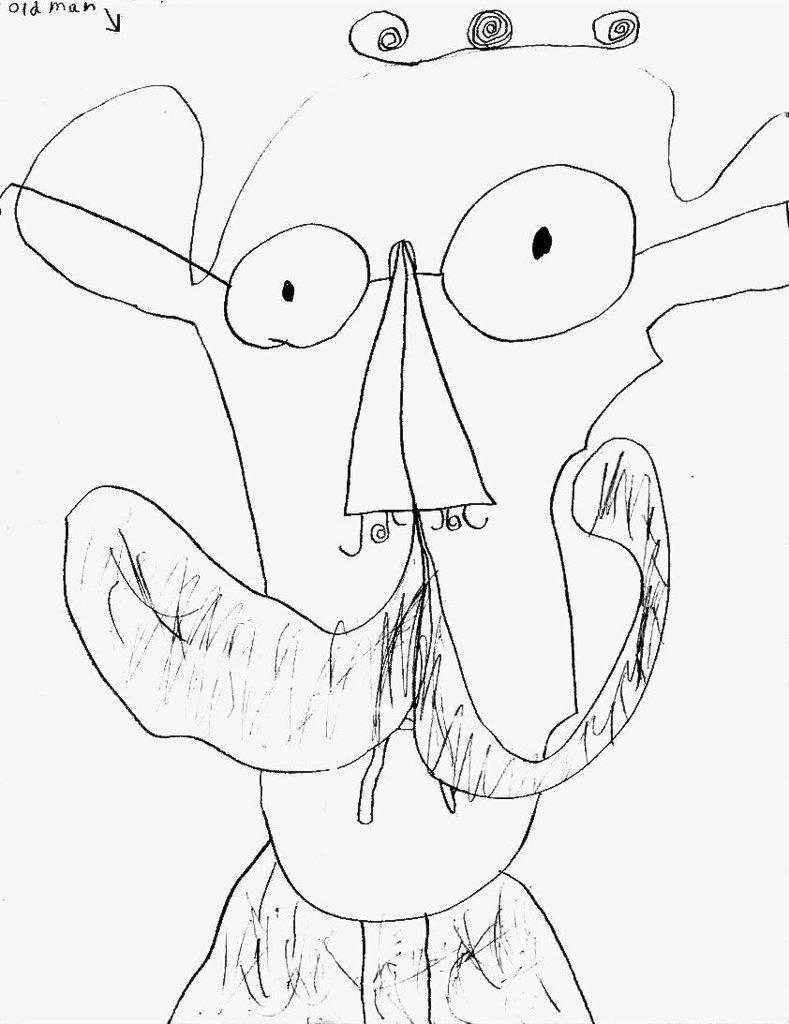Could you give a brief overview of what you see in this image? In the center of the image we can see a drawing of a person. 